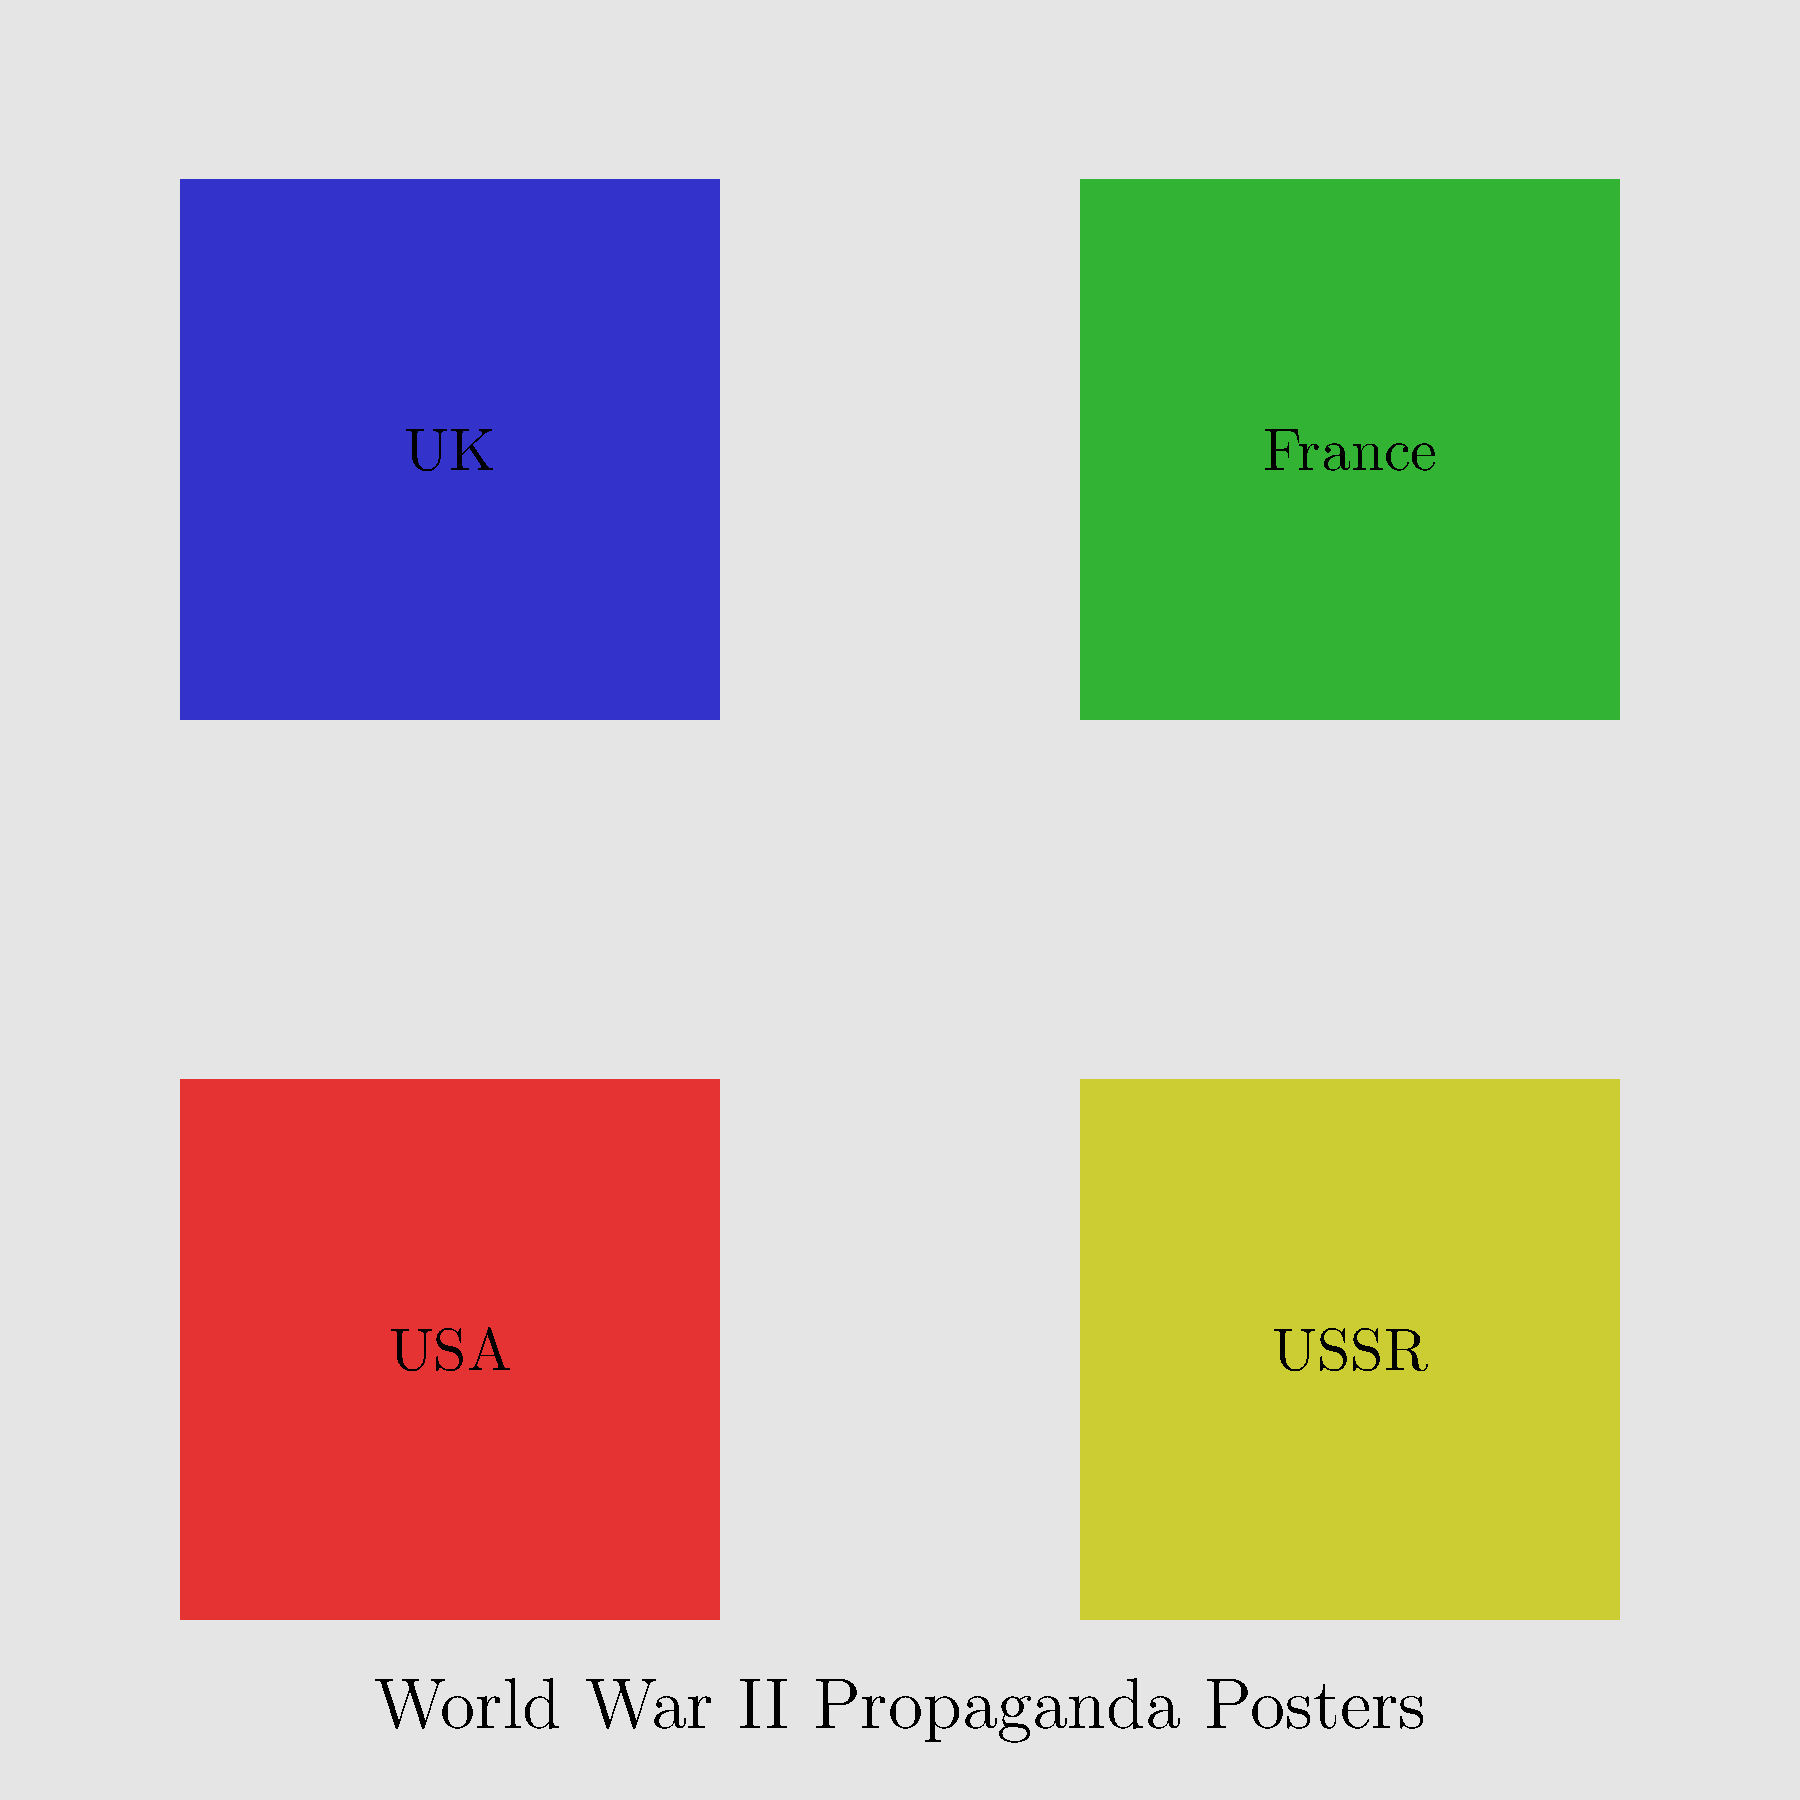Analyze the image showing propaganda posters from different nations during World War II. How might comparing these posters help students develop a more comprehensive understanding of the war's impact on various societies? 1. Multiple perspectives: The image shows propaganda posters from four different nations (USA, USSR, UK, and France) involved in World War II. Each poster represents a unique national perspective on the war.

2. Cultural context: By comparing these posters, students can observe how different cultures and societies portrayed the war, their enemies, and their own roles in the conflict.

3. Political ideologies: The posters likely reflect the political ideologies of each nation, allowing students to understand how different political systems influenced war propaganda.

4. Emotional appeal: Analyzing the visual elements and messages in each poster can reveal the emotional strategies used to mobilize citizens and maintain morale during wartime.

5. Historical accuracy: Comparing these posters with historical facts can help students distinguish between propaganda and reality, developing critical thinking skills.

6. Social impact: By examining posters from various countries, students can better understand how the war affected different societies and how governments communicated with their citizens.

7. Artistic styles: The posters may showcase different artistic styles and techniques, reflecting each nation's cultural and artistic traditions.

8. Language and symbolism: Students can analyze the use of language and symbols in each poster, gaining insight into how different cultures conveyed similar messages.

9. Bias recognition: By comparing multiple perspectives, students can learn to identify bias in historical sources and develop a more nuanced understanding of historical events.

10. Global interconnectedness: Studying propaganda from different nations helps students recognize the global nature of World War II and its far-reaching impacts.
Answer: Develops critical thinking, cultural awareness, and a nuanced global perspective on World War II 